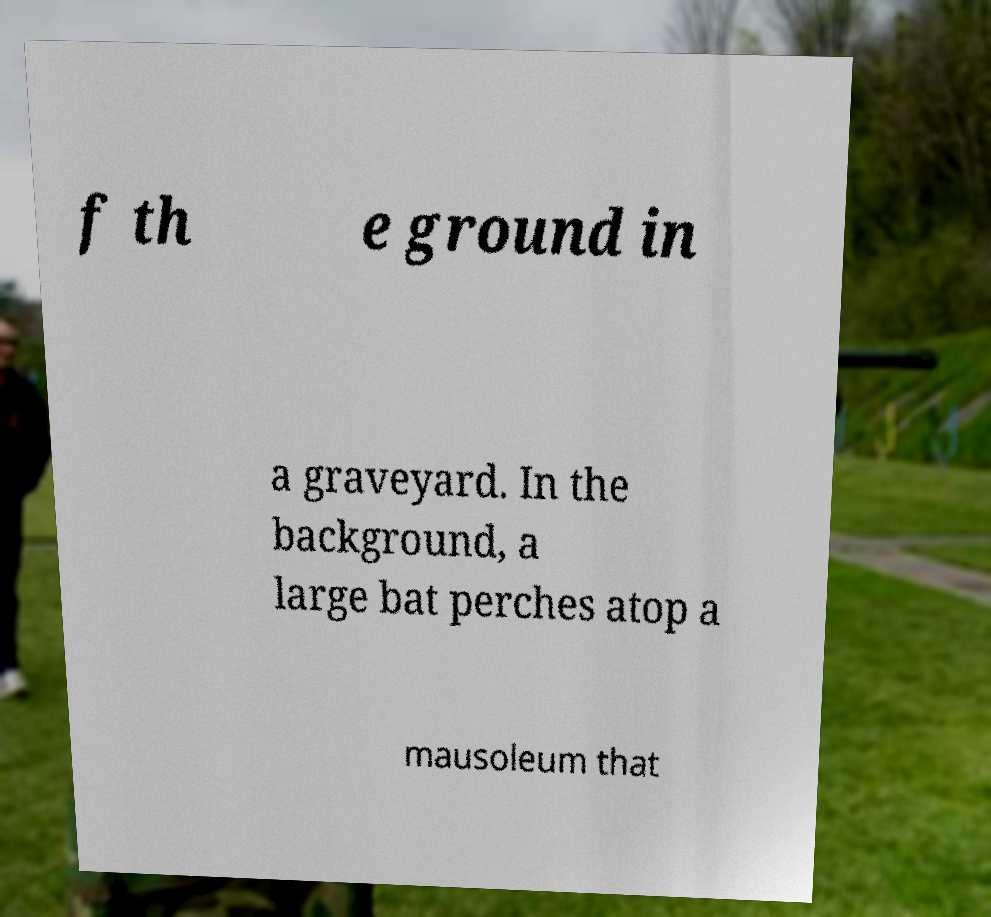Could you assist in decoding the text presented in this image and type it out clearly? f th e ground in a graveyard. In the background, a large bat perches atop a mausoleum that 